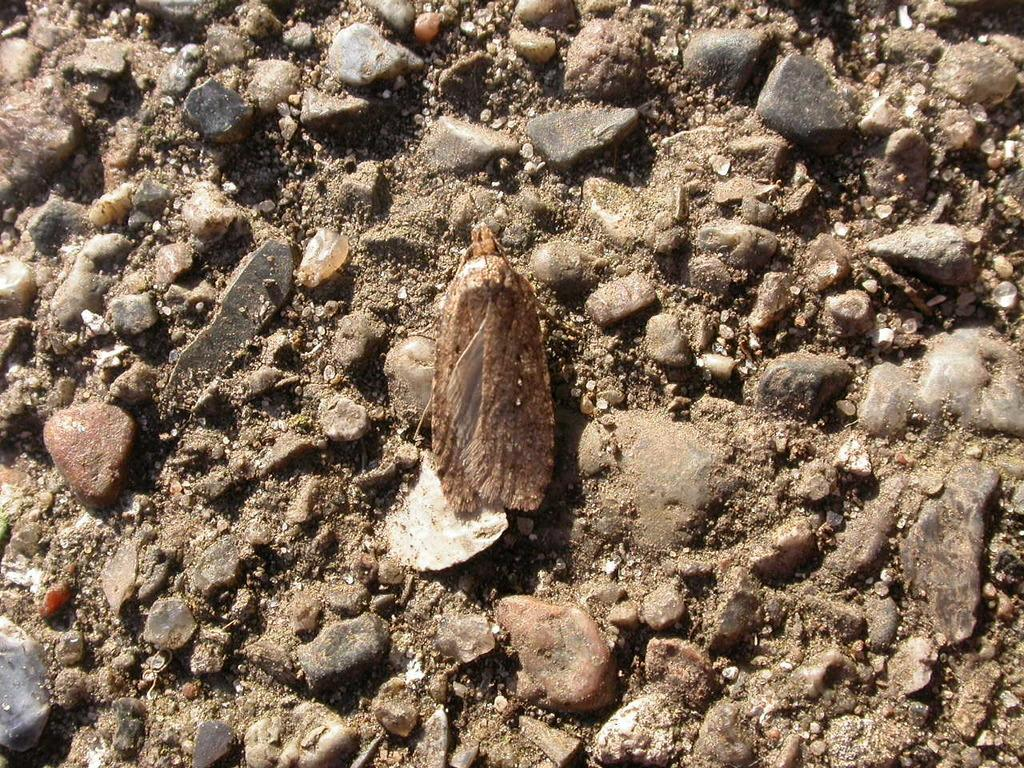What type of objects can be seen in the image? There are stones in the image. Are there any living creatures visible in the image? Yes, there is a brown color insect in the image. Where is the insect located in the image? The insect is on the ground. Can you see a baby playing with the stones in the image? There is no baby present in the image; it only features stones and an insect. 